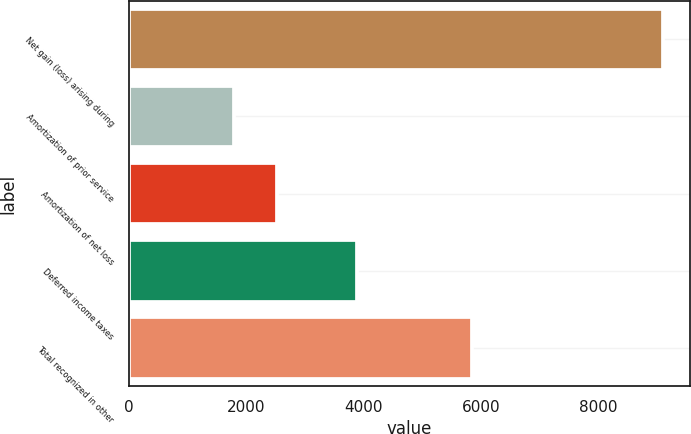Convert chart to OTSL. <chart><loc_0><loc_0><loc_500><loc_500><bar_chart><fcel>Net gain (loss) arising during<fcel>Amortization of prior service<fcel>Amortization of net loss<fcel>Deferred income taxes<fcel>Total recognized in other<nl><fcel>9096<fcel>1799<fcel>2528.7<fcel>3895<fcel>5842<nl></chart> 